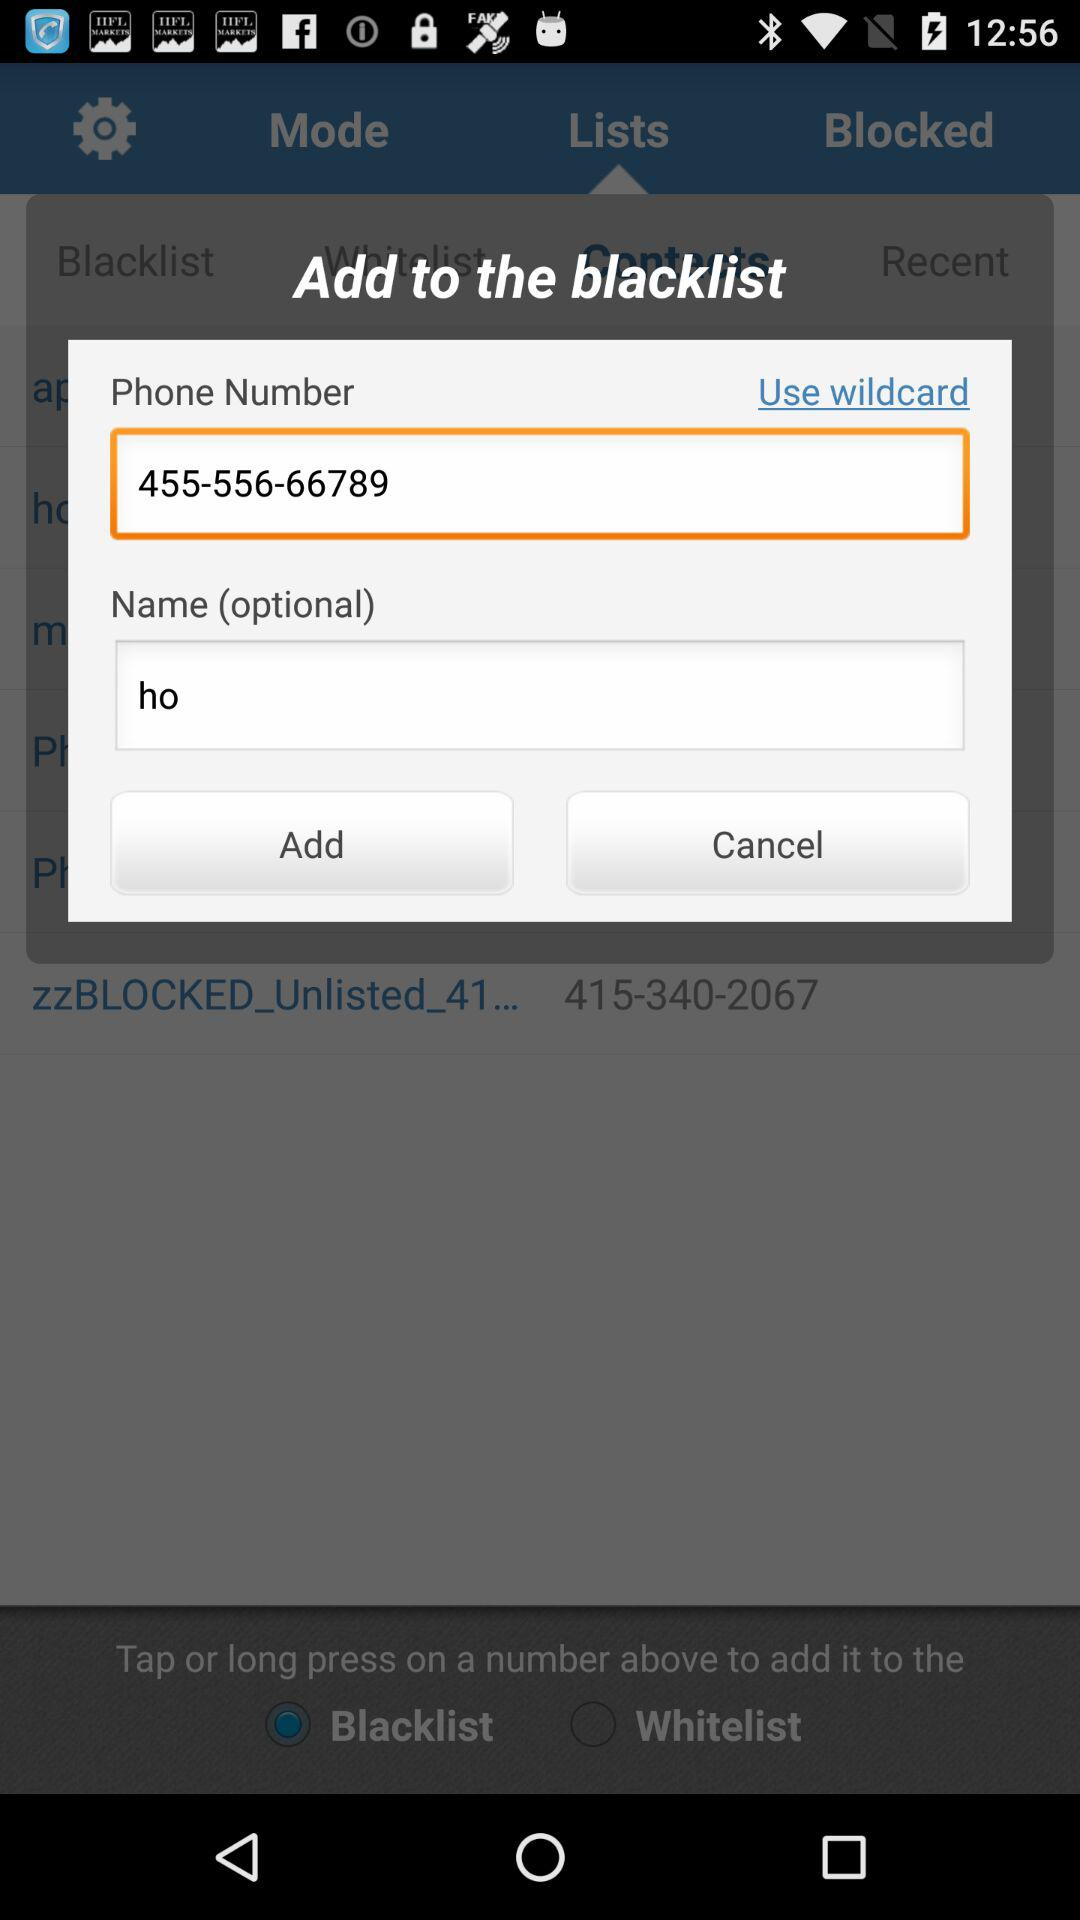Which phone numbers are blocked?
When the provided information is insufficient, respond with <no answer>. <no answer> 